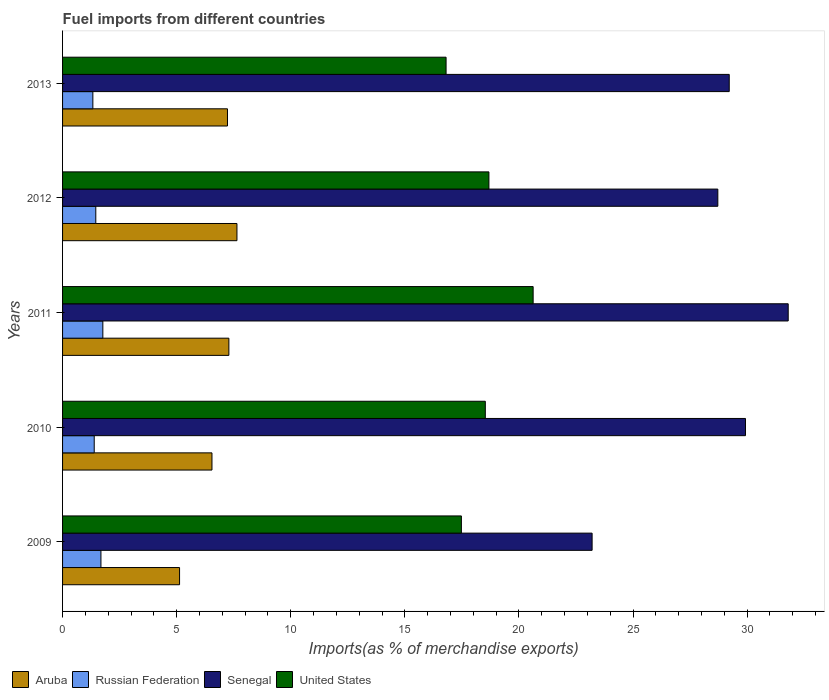How many different coloured bars are there?
Offer a very short reply. 4. How many groups of bars are there?
Offer a terse response. 5. Are the number of bars per tick equal to the number of legend labels?
Make the answer very short. Yes. Are the number of bars on each tick of the Y-axis equal?
Offer a terse response. Yes. How many bars are there on the 1st tick from the top?
Make the answer very short. 4. What is the label of the 2nd group of bars from the top?
Offer a terse response. 2012. What is the percentage of imports to different countries in Russian Federation in 2011?
Provide a short and direct response. 1.77. Across all years, what is the maximum percentage of imports to different countries in Aruba?
Provide a succinct answer. 7.64. Across all years, what is the minimum percentage of imports to different countries in Aruba?
Provide a succinct answer. 5.13. In which year was the percentage of imports to different countries in Russian Federation minimum?
Keep it short and to the point. 2013. What is the total percentage of imports to different countries in Senegal in the graph?
Offer a very short reply. 142.86. What is the difference between the percentage of imports to different countries in United States in 2011 and that in 2013?
Keep it short and to the point. 3.82. What is the difference between the percentage of imports to different countries in Russian Federation in 2010 and the percentage of imports to different countries in Senegal in 2012?
Provide a short and direct response. -27.33. What is the average percentage of imports to different countries in Russian Federation per year?
Ensure brevity in your answer.  1.52. In the year 2009, what is the difference between the percentage of imports to different countries in Senegal and percentage of imports to different countries in United States?
Ensure brevity in your answer.  5.73. In how many years, is the percentage of imports to different countries in Aruba greater than 3 %?
Your answer should be compact. 5. What is the ratio of the percentage of imports to different countries in Aruba in 2010 to that in 2013?
Offer a terse response. 0.91. Is the percentage of imports to different countries in Senegal in 2009 less than that in 2011?
Your answer should be very brief. Yes. Is the difference between the percentage of imports to different countries in Senegal in 2011 and 2012 greater than the difference between the percentage of imports to different countries in United States in 2011 and 2012?
Offer a terse response. Yes. What is the difference between the highest and the second highest percentage of imports to different countries in Senegal?
Make the answer very short. 1.87. What is the difference between the highest and the lowest percentage of imports to different countries in United States?
Your response must be concise. 3.82. Is the sum of the percentage of imports to different countries in Senegal in 2009 and 2012 greater than the maximum percentage of imports to different countries in Aruba across all years?
Offer a terse response. Yes. What does the 3rd bar from the top in 2010 represents?
Make the answer very short. Russian Federation. What does the 2nd bar from the bottom in 2009 represents?
Provide a succinct answer. Russian Federation. How many bars are there?
Give a very brief answer. 20. Are all the bars in the graph horizontal?
Your response must be concise. Yes. Does the graph contain any zero values?
Your answer should be very brief. No. What is the title of the graph?
Provide a short and direct response. Fuel imports from different countries. What is the label or title of the X-axis?
Offer a very short reply. Imports(as % of merchandise exports). What is the label or title of the Y-axis?
Your response must be concise. Years. What is the Imports(as % of merchandise exports) of Aruba in 2009?
Offer a very short reply. 5.13. What is the Imports(as % of merchandise exports) of Russian Federation in 2009?
Offer a terse response. 1.68. What is the Imports(as % of merchandise exports) of Senegal in 2009?
Ensure brevity in your answer.  23.21. What is the Imports(as % of merchandise exports) of United States in 2009?
Give a very brief answer. 17.48. What is the Imports(as % of merchandise exports) in Aruba in 2010?
Your answer should be very brief. 6.55. What is the Imports(as % of merchandise exports) in Russian Federation in 2010?
Your answer should be compact. 1.39. What is the Imports(as % of merchandise exports) of Senegal in 2010?
Ensure brevity in your answer.  29.93. What is the Imports(as % of merchandise exports) of United States in 2010?
Keep it short and to the point. 18.53. What is the Imports(as % of merchandise exports) of Aruba in 2011?
Your response must be concise. 7.29. What is the Imports(as % of merchandise exports) of Russian Federation in 2011?
Your response must be concise. 1.77. What is the Imports(as % of merchandise exports) of Senegal in 2011?
Your answer should be very brief. 31.8. What is the Imports(as % of merchandise exports) of United States in 2011?
Give a very brief answer. 20.62. What is the Imports(as % of merchandise exports) of Aruba in 2012?
Ensure brevity in your answer.  7.64. What is the Imports(as % of merchandise exports) of Russian Federation in 2012?
Offer a very short reply. 1.46. What is the Imports(as % of merchandise exports) of Senegal in 2012?
Ensure brevity in your answer.  28.72. What is the Imports(as % of merchandise exports) of United States in 2012?
Keep it short and to the point. 18.68. What is the Imports(as % of merchandise exports) in Aruba in 2013?
Your answer should be compact. 7.23. What is the Imports(as % of merchandise exports) in Russian Federation in 2013?
Keep it short and to the point. 1.33. What is the Imports(as % of merchandise exports) in Senegal in 2013?
Offer a terse response. 29.22. What is the Imports(as % of merchandise exports) of United States in 2013?
Your response must be concise. 16.81. Across all years, what is the maximum Imports(as % of merchandise exports) of Aruba?
Offer a very short reply. 7.64. Across all years, what is the maximum Imports(as % of merchandise exports) of Russian Federation?
Your response must be concise. 1.77. Across all years, what is the maximum Imports(as % of merchandise exports) of Senegal?
Your answer should be very brief. 31.8. Across all years, what is the maximum Imports(as % of merchandise exports) in United States?
Provide a short and direct response. 20.62. Across all years, what is the minimum Imports(as % of merchandise exports) in Aruba?
Offer a very short reply. 5.13. Across all years, what is the minimum Imports(as % of merchandise exports) in Russian Federation?
Give a very brief answer. 1.33. Across all years, what is the minimum Imports(as % of merchandise exports) of Senegal?
Offer a very short reply. 23.21. Across all years, what is the minimum Imports(as % of merchandise exports) in United States?
Make the answer very short. 16.81. What is the total Imports(as % of merchandise exports) of Aruba in the graph?
Your answer should be very brief. 33.83. What is the total Imports(as % of merchandise exports) of Russian Federation in the graph?
Provide a short and direct response. 7.62. What is the total Imports(as % of merchandise exports) in Senegal in the graph?
Offer a very short reply. 142.86. What is the total Imports(as % of merchandise exports) in United States in the graph?
Keep it short and to the point. 92.12. What is the difference between the Imports(as % of merchandise exports) in Aruba in 2009 and that in 2010?
Give a very brief answer. -1.42. What is the difference between the Imports(as % of merchandise exports) in Russian Federation in 2009 and that in 2010?
Provide a succinct answer. 0.29. What is the difference between the Imports(as % of merchandise exports) in Senegal in 2009 and that in 2010?
Your response must be concise. -6.72. What is the difference between the Imports(as % of merchandise exports) of United States in 2009 and that in 2010?
Offer a very short reply. -1.05. What is the difference between the Imports(as % of merchandise exports) of Aruba in 2009 and that in 2011?
Give a very brief answer. -2.16. What is the difference between the Imports(as % of merchandise exports) in Russian Federation in 2009 and that in 2011?
Offer a very short reply. -0.08. What is the difference between the Imports(as % of merchandise exports) of Senegal in 2009 and that in 2011?
Keep it short and to the point. -8.59. What is the difference between the Imports(as % of merchandise exports) in United States in 2009 and that in 2011?
Offer a terse response. -3.14. What is the difference between the Imports(as % of merchandise exports) of Aruba in 2009 and that in 2012?
Your response must be concise. -2.51. What is the difference between the Imports(as % of merchandise exports) in Russian Federation in 2009 and that in 2012?
Your answer should be compact. 0.23. What is the difference between the Imports(as % of merchandise exports) in Senegal in 2009 and that in 2012?
Give a very brief answer. -5.51. What is the difference between the Imports(as % of merchandise exports) in United States in 2009 and that in 2012?
Your response must be concise. -1.21. What is the difference between the Imports(as % of merchandise exports) in Aruba in 2009 and that in 2013?
Your answer should be compact. -2.1. What is the difference between the Imports(as % of merchandise exports) of Russian Federation in 2009 and that in 2013?
Your response must be concise. 0.35. What is the difference between the Imports(as % of merchandise exports) in Senegal in 2009 and that in 2013?
Give a very brief answer. -6.01. What is the difference between the Imports(as % of merchandise exports) in United States in 2009 and that in 2013?
Provide a short and direct response. 0.67. What is the difference between the Imports(as % of merchandise exports) in Aruba in 2010 and that in 2011?
Keep it short and to the point. -0.74. What is the difference between the Imports(as % of merchandise exports) of Russian Federation in 2010 and that in 2011?
Your response must be concise. -0.38. What is the difference between the Imports(as % of merchandise exports) in Senegal in 2010 and that in 2011?
Your answer should be very brief. -1.87. What is the difference between the Imports(as % of merchandise exports) in United States in 2010 and that in 2011?
Offer a terse response. -2.1. What is the difference between the Imports(as % of merchandise exports) of Aruba in 2010 and that in 2012?
Offer a very short reply. -1.09. What is the difference between the Imports(as % of merchandise exports) in Russian Federation in 2010 and that in 2012?
Your answer should be very brief. -0.07. What is the difference between the Imports(as % of merchandise exports) in Senegal in 2010 and that in 2012?
Keep it short and to the point. 1.21. What is the difference between the Imports(as % of merchandise exports) in United States in 2010 and that in 2012?
Make the answer very short. -0.16. What is the difference between the Imports(as % of merchandise exports) in Aruba in 2010 and that in 2013?
Provide a short and direct response. -0.68. What is the difference between the Imports(as % of merchandise exports) in Russian Federation in 2010 and that in 2013?
Keep it short and to the point. 0.06. What is the difference between the Imports(as % of merchandise exports) in Senegal in 2010 and that in 2013?
Your answer should be very brief. 0.71. What is the difference between the Imports(as % of merchandise exports) in United States in 2010 and that in 2013?
Your answer should be compact. 1.72. What is the difference between the Imports(as % of merchandise exports) in Aruba in 2011 and that in 2012?
Provide a succinct answer. -0.35. What is the difference between the Imports(as % of merchandise exports) of Russian Federation in 2011 and that in 2012?
Make the answer very short. 0.31. What is the difference between the Imports(as % of merchandise exports) in Senegal in 2011 and that in 2012?
Make the answer very short. 3.08. What is the difference between the Imports(as % of merchandise exports) of United States in 2011 and that in 2012?
Ensure brevity in your answer.  1.94. What is the difference between the Imports(as % of merchandise exports) of Aruba in 2011 and that in 2013?
Offer a very short reply. 0.06. What is the difference between the Imports(as % of merchandise exports) of Russian Federation in 2011 and that in 2013?
Offer a very short reply. 0.44. What is the difference between the Imports(as % of merchandise exports) in Senegal in 2011 and that in 2013?
Give a very brief answer. 2.58. What is the difference between the Imports(as % of merchandise exports) in United States in 2011 and that in 2013?
Offer a very short reply. 3.82. What is the difference between the Imports(as % of merchandise exports) in Aruba in 2012 and that in 2013?
Offer a terse response. 0.41. What is the difference between the Imports(as % of merchandise exports) of Russian Federation in 2012 and that in 2013?
Make the answer very short. 0.13. What is the difference between the Imports(as % of merchandise exports) of Senegal in 2012 and that in 2013?
Your response must be concise. -0.5. What is the difference between the Imports(as % of merchandise exports) of United States in 2012 and that in 2013?
Provide a short and direct response. 1.88. What is the difference between the Imports(as % of merchandise exports) in Aruba in 2009 and the Imports(as % of merchandise exports) in Russian Federation in 2010?
Your response must be concise. 3.74. What is the difference between the Imports(as % of merchandise exports) in Aruba in 2009 and the Imports(as % of merchandise exports) in Senegal in 2010?
Give a very brief answer. -24.8. What is the difference between the Imports(as % of merchandise exports) in Aruba in 2009 and the Imports(as % of merchandise exports) in United States in 2010?
Your response must be concise. -13.4. What is the difference between the Imports(as % of merchandise exports) in Russian Federation in 2009 and the Imports(as % of merchandise exports) in Senegal in 2010?
Give a very brief answer. -28.25. What is the difference between the Imports(as % of merchandise exports) of Russian Federation in 2009 and the Imports(as % of merchandise exports) of United States in 2010?
Ensure brevity in your answer.  -16.84. What is the difference between the Imports(as % of merchandise exports) in Senegal in 2009 and the Imports(as % of merchandise exports) in United States in 2010?
Your answer should be compact. 4.68. What is the difference between the Imports(as % of merchandise exports) in Aruba in 2009 and the Imports(as % of merchandise exports) in Russian Federation in 2011?
Offer a terse response. 3.36. What is the difference between the Imports(as % of merchandise exports) in Aruba in 2009 and the Imports(as % of merchandise exports) in Senegal in 2011?
Give a very brief answer. -26.67. What is the difference between the Imports(as % of merchandise exports) in Aruba in 2009 and the Imports(as % of merchandise exports) in United States in 2011?
Ensure brevity in your answer.  -15.49. What is the difference between the Imports(as % of merchandise exports) in Russian Federation in 2009 and the Imports(as % of merchandise exports) in Senegal in 2011?
Provide a short and direct response. -30.12. What is the difference between the Imports(as % of merchandise exports) in Russian Federation in 2009 and the Imports(as % of merchandise exports) in United States in 2011?
Your answer should be compact. -18.94. What is the difference between the Imports(as % of merchandise exports) in Senegal in 2009 and the Imports(as % of merchandise exports) in United States in 2011?
Provide a short and direct response. 2.58. What is the difference between the Imports(as % of merchandise exports) in Aruba in 2009 and the Imports(as % of merchandise exports) in Russian Federation in 2012?
Your response must be concise. 3.67. What is the difference between the Imports(as % of merchandise exports) of Aruba in 2009 and the Imports(as % of merchandise exports) of Senegal in 2012?
Make the answer very short. -23.59. What is the difference between the Imports(as % of merchandise exports) in Aruba in 2009 and the Imports(as % of merchandise exports) in United States in 2012?
Offer a very short reply. -13.56. What is the difference between the Imports(as % of merchandise exports) in Russian Federation in 2009 and the Imports(as % of merchandise exports) in Senegal in 2012?
Your answer should be very brief. -27.03. What is the difference between the Imports(as % of merchandise exports) in Russian Federation in 2009 and the Imports(as % of merchandise exports) in United States in 2012?
Your answer should be very brief. -17. What is the difference between the Imports(as % of merchandise exports) in Senegal in 2009 and the Imports(as % of merchandise exports) in United States in 2012?
Provide a succinct answer. 4.52. What is the difference between the Imports(as % of merchandise exports) of Aruba in 2009 and the Imports(as % of merchandise exports) of Russian Federation in 2013?
Give a very brief answer. 3.8. What is the difference between the Imports(as % of merchandise exports) in Aruba in 2009 and the Imports(as % of merchandise exports) in Senegal in 2013?
Provide a short and direct response. -24.09. What is the difference between the Imports(as % of merchandise exports) of Aruba in 2009 and the Imports(as % of merchandise exports) of United States in 2013?
Give a very brief answer. -11.68. What is the difference between the Imports(as % of merchandise exports) of Russian Federation in 2009 and the Imports(as % of merchandise exports) of Senegal in 2013?
Offer a terse response. -27.53. What is the difference between the Imports(as % of merchandise exports) of Russian Federation in 2009 and the Imports(as % of merchandise exports) of United States in 2013?
Your response must be concise. -15.13. What is the difference between the Imports(as % of merchandise exports) of Senegal in 2009 and the Imports(as % of merchandise exports) of United States in 2013?
Your answer should be compact. 6.4. What is the difference between the Imports(as % of merchandise exports) in Aruba in 2010 and the Imports(as % of merchandise exports) in Russian Federation in 2011?
Provide a succinct answer. 4.78. What is the difference between the Imports(as % of merchandise exports) in Aruba in 2010 and the Imports(as % of merchandise exports) in Senegal in 2011?
Provide a short and direct response. -25.25. What is the difference between the Imports(as % of merchandise exports) of Aruba in 2010 and the Imports(as % of merchandise exports) of United States in 2011?
Offer a very short reply. -14.07. What is the difference between the Imports(as % of merchandise exports) of Russian Federation in 2010 and the Imports(as % of merchandise exports) of Senegal in 2011?
Make the answer very short. -30.41. What is the difference between the Imports(as % of merchandise exports) in Russian Federation in 2010 and the Imports(as % of merchandise exports) in United States in 2011?
Offer a terse response. -19.23. What is the difference between the Imports(as % of merchandise exports) in Senegal in 2010 and the Imports(as % of merchandise exports) in United States in 2011?
Your response must be concise. 9.3. What is the difference between the Imports(as % of merchandise exports) in Aruba in 2010 and the Imports(as % of merchandise exports) in Russian Federation in 2012?
Your response must be concise. 5.09. What is the difference between the Imports(as % of merchandise exports) of Aruba in 2010 and the Imports(as % of merchandise exports) of Senegal in 2012?
Give a very brief answer. -22.17. What is the difference between the Imports(as % of merchandise exports) in Aruba in 2010 and the Imports(as % of merchandise exports) in United States in 2012?
Offer a terse response. -12.14. What is the difference between the Imports(as % of merchandise exports) of Russian Federation in 2010 and the Imports(as % of merchandise exports) of Senegal in 2012?
Your answer should be very brief. -27.33. What is the difference between the Imports(as % of merchandise exports) in Russian Federation in 2010 and the Imports(as % of merchandise exports) in United States in 2012?
Ensure brevity in your answer.  -17.3. What is the difference between the Imports(as % of merchandise exports) of Senegal in 2010 and the Imports(as % of merchandise exports) of United States in 2012?
Make the answer very short. 11.24. What is the difference between the Imports(as % of merchandise exports) of Aruba in 2010 and the Imports(as % of merchandise exports) of Russian Federation in 2013?
Give a very brief answer. 5.22. What is the difference between the Imports(as % of merchandise exports) of Aruba in 2010 and the Imports(as % of merchandise exports) of Senegal in 2013?
Offer a terse response. -22.67. What is the difference between the Imports(as % of merchandise exports) in Aruba in 2010 and the Imports(as % of merchandise exports) in United States in 2013?
Offer a terse response. -10.26. What is the difference between the Imports(as % of merchandise exports) in Russian Federation in 2010 and the Imports(as % of merchandise exports) in Senegal in 2013?
Your answer should be compact. -27.83. What is the difference between the Imports(as % of merchandise exports) in Russian Federation in 2010 and the Imports(as % of merchandise exports) in United States in 2013?
Provide a short and direct response. -15.42. What is the difference between the Imports(as % of merchandise exports) of Senegal in 2010 and the Imports(as % of merchandise exports) of United States in 2013?
Ensure brevity in your answer.  13.12. What is the difference between the Imports(as % of merchandise exports) of Aruba in 2011 and the Imports(as % of merchandise exports) of Russian Federation in 2012?
Your answer should be very brief. 5.83. What is the difference between the Imports(as % of merchandise exports) of Aruba in 2011 and the Imports(as % of merchandise exports) of Senegal in 2012?
Keep it short and to the point. -21.43. What is the difference between the Imports(as % of merchandise exports) of Aruba in 2011 and the Imports(as % of merchandise exports) of United States in 2012?
Provide a succinct answer. -11.4. What is the difference between the Imports(as % of merchandise exports) of Russian Federation in 2011 and the Imports(as % of merchandise exports) of Senegal in 2012?
Give a very brief answer. -26.95. What is the difference between the Imports(as % of merchandise exports) of Russian Federation in 2011 and the Imports(as % of merchandise exports) of United States in 2012?
Provide a succinct answer. -16.92. What is the difference between the Imports(as % of merchandise exports) in Senegal in 2011 and the Imports(as % of merchandise exports) in United States in 2012?
Offer a very short reply. 13.12. What is the difference between the Imports(as % of merchandise exports) of Aruba in 2011 and the Imports(as % of merchandise exports) of Russian Federation in 2013?
Your answer should be compact. 5.96. What is the difference between the Imports(as % of merchandise exports) of Aruba in 2011 and the Imports(as % of merchandise exports) of Senegal in 2013?
Offer a terse response. -21.93. What is the difference between the Imports(as % of merchandise exports) in Aruba in 2011 and the Imports(as % of merchandise exports) in United States in 2013?
Your answer should be compact. -9.52. What is the difference between the Imports(as % of merchandise exports) of Russian Federation in 2011 and the Imports(as % of merchandise exports) of Senegal in 2013?
Keep it short and to the point. -27.45. What is the difference between the Imports(as % of merchandise exports) in Russian Federation in 2011 and the Imports(as % of merchandise exports) in United States in 2013?
Your answer should be very brief. -15.04. What is the difference between the Imports(as % of merchandise exports) in Senegal in 2011 and the Imports(as % of merchandise exports) in United States in 2013?
Ensure brevity in your answer.  14.99. What is the difference between the Imports(as % of merchandise exports) in Aruba in 2012 and the Imports(as % of merchandise exports) in Russian Federation in 2013?
Provide a succinct answer. 6.31. What is the difference between the Imports(as % of merchandise exports) of Aruba in 2012 and the Imports(as % of merchandise exports) of Senegal in 2013?
Make the answer very short. -21.57. What is the difference between the Imports(as % of merchandise exports) in Aruba in 2012 and the Imports(as % of merchandise exports) in United States in 2013?
Give a very brief answer. -9.16. What is the difference between the Imports(as % of merchandise exports) of Russian Federation in 2012 and the Imports(as % of merchandise exports) of Senegal in 2013?
Ensure brevity in your answer.  -27.76. What is the difference between the Imports(as % of merchandise exports) in Russian Federation in 2012 and the Imports(as % of merchandise exports) in United States in 2013?
Your answer should be very brief. -15.35. What is the difference between the Imports(as % of merchandise exports) of Senegal in 2012 and the Imports(as % of merchandise exports) of United States in 2013?
Your answer should be compact. 11.91. What is the average Imports(as % of merchandise exports) in Aruba per year?
Your answer should be compact. 6.77. What is the average Imports(as % of merchandise exports) in Russian Federation per year?
Ensure brevity in your answer.  1.52. What is the average Imports(as % of merchandise exports) of Senegal per year?
Offer a terse response. 28.57. What is the average Imports(as % of merchandise exports) in United States per year?
Offer a very short reply. 18.42. In the year 2009, what is the difference between the Imports(as % of merchandise exports) in Aruba and Imports(as % of merchandise exports) in Russian Federation?
Offer a very short reply. 3.45. In the year 2009, what is the difference between the Imports(as % of merchandise exports) of Aruba and Imports(as % of merchandise exports) of Senegal?
Keep it short and to the point. -18.08. In the year 2009, what is the difference between the Imports(as % of merchandise exports) of Aruba and Imports(as % of merchandise exports) of United States?
Your response must be concise. -12.35. In the year 2009, what is the difference between the Imports(as % of merchandise exports) of Russian Federation and Imports(as % of merchandise exports) of Senegal?
Provide a succinct answer. -21.52. In the year 2009, what is the difference between the Imports(as % of merchandise exports) of Russian Federation and Imports(as % of merchandise exports) of United States?
Your answer should be very brief. -15.8. In the year 2009, what is the difference between the Imports(as % of merchandise exports) of Senegal and Imports(as % of merchandise exports) of United States?
Make the answer very short. 5.73. In the year 2010, what is the difference between the Imports(as % of merchandise exports) in Aruba and Imports(as % of merchandise exports) in Russian Federation?
Your response must be concise. 5.16. In the year 2010, what is the difference between the Imports(as % of merchandise exports) in Aruba and Imports(as % of merchandise exports) in Senegal?
Provide a succinct answer. -23.38. In the year 2010, what is the difference between the Imports(as % of merchandise exports) in Aruba and Imports(as % of merchandise exports) in United States?
Make the answer very short. -11.98. In the year 2010, what is the difference between the Imports(as % of merchandise exports) in Russian Federation and Imports(as % of merchandise exports) in Senegal?
Keep it short and to the point. -28.54. In the year 2010, what is the difference between the Imports(as % of merchandise exports) in Russian Federation and Imports(as % of merchandise exports) in United States?
Offer a terse response. -17.14. In the year 2010, what is the difference between the Imports(as % of merchandise exports) in Senegal and Imports(as % of merchandise exports) in United States?
Your answer should be compact. 11.4. In the year 2011, what is the difference between the Imports(as % of merchandise exports) in Aruba and Imports(as % of merchandise exports) in Russian Federation?
Keep it short and to the point. 5.52. In the year 2011, what is the difference between the Imports(as % of merchandise exports) of Aruba and Imports(as % of merchandise exports) of Senegal?
Ensure brevity in your answer.  -24.51. In the year 2011, what is the difference between the Imports(as % of merchandise exports) in Aruba and Imports(as % of merchandise exports) in United States?
Offer a very short reply. -13.33. In the year 2011, what is the difference between the Imports(as % of merchandise exports) of Russian Federation and Imports(as % of merchandise exports) of Senegal?
Give a very brief answer. -30.03. In the year 2011, what is the difference between the Imports(as % of merchandise exports) of Russian Federation and Imports(as % of merchandise exports) of United States?
Give a very brief answer. -18.86. In the year 2011, what is the difference between the Imports(as % of merchandise exports) of Senegal and Imports(as % of merchandise exports) of United States?
Provide a short and direct response. 11.18. In the year 2012, what is the difference between the Imports(as % of merchandise exports) of Aruba and Imports(as % of merchandise exports) of Russian Federation?
Ensure brevity in your answer.  6.19. In the year 2012, what is the difference between the Imports(as % of merchandise exports) in Aruba and Imports(as % of merchandise exports) in Senegal?
Your answer should be very brief. -21.07. In the year 2012, what is the difference between the Imports(as % of merchandise exports) in Aruba and Imports(as % of merchandise exports) in United States?
Provide a succinct answer. -11.04. In the year 2012, what is the difference between the Imports(as % of merchandise exports) in Russian Federation and Imports(as % of merchandise exports) in Senegal?
Give a very brief answer. -27.26. In the year 2012, what is the difference between the Imports(as % of merchandise exports) of Russian Federation and Imports(as % of merchandise exports) of United States?
Provide a succinct answer. -17.23. In the year 2012, what is the difference between the Imports(as % of merchandise exports) in Senegal and Imports(as % of merchandise exports) in United States?
Keep it short and to the point. 10.03. In the year 2013, what is the difference between the Imports(as % of merchandise exports) of Aruba and Imports(as % of merchandise exports) of Russian Federation?
Make the answer very short. 5.9. In the year 2013, what is the difference between the Imports(as % of merchandise exports) of Aruba and Imports(as % of merchandise exports) of Senegal?
Provide a succinct answer. -21.99. In the year 2013, what is the difference between the Imports(as % of merchandise exports) of Aruba and Imports(as % of merchandise exports) of United States?
Provide a short and direct response. -9.58. In the year 2013, what is the difference between the Imports(as % of merchandise exports) of Russian Federation and Imports(as % of merchandise exports) of Senegal?
Provide a short and direct response. -27.89. In the year 2013, what is the difference between the Imports(as % of merchandise exports) of Russian Federation and Imports(as % of merchandise exports) of United States?
Your answer should be compact. -15.48. In the year 2013, what is the difference between the Imports(as % of merchandise exports) in Senegal and Imports(as % of merchandise exports) in United States?
Give a very brief answer. 12.41. What is the ratio of the Imports(as % of merchandise exports) of Aruba in 2009 to that in 2010?
Your response must be concise. 0.78. What is the ratio of the Imports(as % of merchandise exports) of Russian Federation in 2009 to that in 2010?
Make the answer very short. 1.21. What is the ratio of the Imports(as % of merchandise exports) in Senegal in 2009 to that in 2010?
Provide a succinct answer. 0.78. What is the ratio of the Imports(as % of merchandise exports) of United States in 2009 to that in 2010?
Your answer should be very brief. 0.94. What is the ratio of the Imports(as % of merchandise exports) of Aruba in 2009 to that in 2011?
Give a very brief answer. 0.7. What is the ratio of the Imports(as % of merchandise exports) of Russian Federation in 2009 to that in 2011?
Give a very brief answer. 0.95. What is the ratio of the Imports(as % of merchandise exports) of Senegal in 2009 to that in 2011?
Provide a short and direct response. 0.73. What is the ratio of the Imports(as % of merchandise exports) in United States in 2009 to that in 2011?
Provide a short and direct response. 0.85. What is the ratio of the Imports(as % of merchandise exports) of Aruba in 2009 to that in 2012?
Provide a succinct answer. 0.67. What is the ratio of the Imports(as % of merchandise exports) of Russian Federation in 2009 to that in 2012?
Offer a very short reply. 1.16. What is the ratio of the Imports(as % of merchandise exports) in Senegal in 2009 to that in 2012?
Offer a terse response. 0.81. What is the ratio of the Imports(as % of merchandise exports) in United States in 2009 to that in 2012?
Provide a short and direct response. 0.94. What is the ratio of the Imports(as % of merchandise exports) of Aruba in 2009 to that in 2013?
Give a very brief answer. 0.71. What is the ratio of the Imports(as % of merchandise exports) in Russian Federation in 2009 to that in 2013?
Provide a succinct answer. 1.27. What is the ratio of the Imports(as % of merchandise exports) of Senegal in 2009 to that in 2013?
Make the answer very short. 0.79. What is the ratio of the Imports(as % of merchandise exports) in United States in 2009 to that in 2013?
Give a very brief answer. 1.04. What is the ratio of the Imports(as % of merchandise exports) in Aruba in 2010 to that in 2011?
Provide a succinct answer. 0.9. What is the ratio of the Imports(as % of merchandise exports) of Russian Federation in 2010 to that in 2011?
Provide a short and direct response. 0.79. What is the ratio of the Imports(as % of merchandise exports) in Senegal in 2010 to that in 2011?
Provide a succinct answer. 0.94. What is the ratio of the Imports(as % of merchandise exports) in United States in 2010 to that in 2011?
Your response must be concise. 0.9. What is the ratio of the Imports(as % of merchandise exports) of Aruba in 2010 to that in 2012?
Ensure brevity in your answer.  0.86. What is the ratio of the Imports(as % of merchandise exports) in Russian Federation in 2010 to that in 2012?
Keep it short and to the point. 0.95. What is the ratio of the Imports(as % of merchandise exports) of Senegal in 2010 to that in 2012?
Offer a terse response. 1.04. What is the ratio of the Imports(as % of merchandise exports) of Aruba in 2010 to that in 2013?
Provide a short and direct response. 0.91. What is the ratio of the Imports(as % of merchandise exports) in Russian Federation in 2010 to that in 2013?
Ensure brevity in your answer.  1.04. What is the ratio of the Imports(as % of merchandise exports) of Senegal in 2010 to that in 2013?
Your answer should be very brief. 1.02. What is the ratio of the Imports(as % of merchandise exports) of United States in 2010 to that in 2013?
Provide a succinct answer. 1.1. What is the ratio of the Imports(as % of merchandise exports) in Aruba in 2011 to that in 2012?
Provide a short and direct response. 0.95. What is the ratio of the Imports(as % of merchandise exports) in Russian Federation in 2011 to that in 2012?
Keep it short and to the point. 1.21. What is the ratio of the Imports(as % of merchandise exports) in Senegal in 2011 to that in 2012?
Your answer should be compact. 1.11. What is the ratio of the Imports(as % of merchandise exports) of United States in 2011 to that in 2012?
Provide a succinct answer. 1.1. What is the ratio of the Imports(as % of merchandise exports) of Aruba in 2011 to that in 2013?
Your answer should be very brief. 1.01. What is the ratio of the Imports(as % of merchandise exports) of Russian Federation in 2011 to that in 2013?
Your answer should be very brief. 1.33. What is the ratio of the Imports(as % of merchandise exports) in Senegal in 2011 to that in 2013?
Give a very brief answer. 1.09. What is the ratio of the Imports(as % of merchandise exports) in United States in 2011 to that in 2013?
Offer a terse response. 1.23. What is the ratio of the Imports(as % of merchandise exports) of Aruba in 2012 to that in 2013?
Keep it short and to the point. 1.06. What is the ratio of the Imports(as % of merchandise exports) in Russian Federation in 2012 to that in 2013?
Offer a very short reply. 1.1. What is the ratio of the Imports(as % of merchandise exports) of Senegal in 2012 to that in 2013?
Ensure brevity in your answer.  0.98. What is the ratio of the Imports(as % of merchandise exports) of United States in 2012 to that in 2013?
Your answer should be very brief. 1.11. What is the difference between the highest and the second highest Imports(as % of merchandise exports) of Aruba?
Your answer should be compact. 0.35. What is the difference between the highest and the second highest Imports(as % of merchandise exports) of Russian Federation?
Your answer should be compact. 0.08. What is the difference between the highest and the second highest Imports(as % of merchandise exports) in Senegal?
Offer a very short reply. 1.87. What is the difference between the highest and the second highest Imports(as % of merchandise exports) in United States?
Your response must be concise. 1.94. What is the difference between the highest and the lowest Imports(as % of merchandise exports) of Aruba?
Provide a short and direct response. 2.51. What is the difference between the highest and the lowest Imports(as % of merchandise exports) in Russian Federation?
Keep it short and to the point. 0.44. What is the difference between the highest and the lowest Imports(as % of merchandise exports) in Senegal?
Offer a terse response. 8.59. What is the difference between the highest and the lowest Imports(as % of merchandise exports) of United States?
Your answer should be compact. 3.82. 